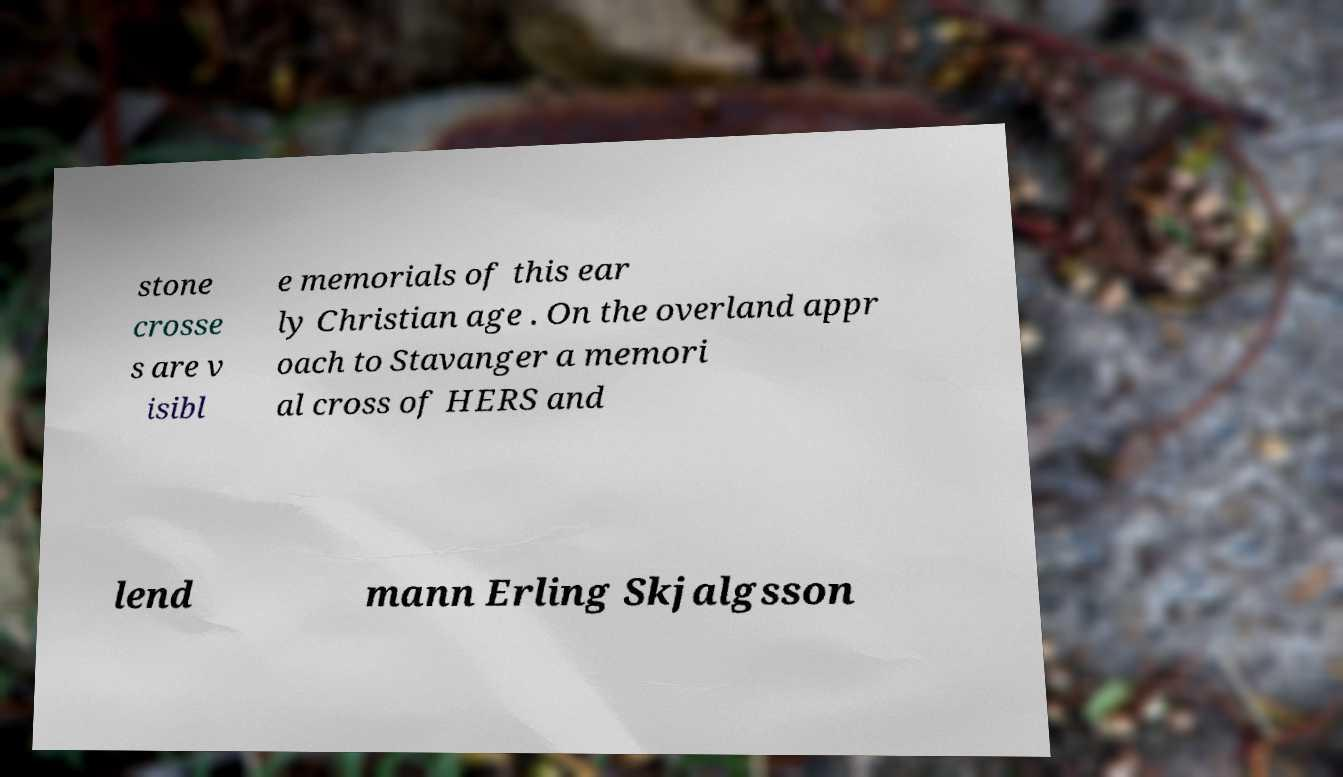What messages or text are displayed in this image? I need them in a readable, typed format. stone crosse s are v isibl e memorials of this ear ly Christian age . On the overland appr oach to Stavanger a memori al cross of HERS and lend mann Erling Skjalgsson 